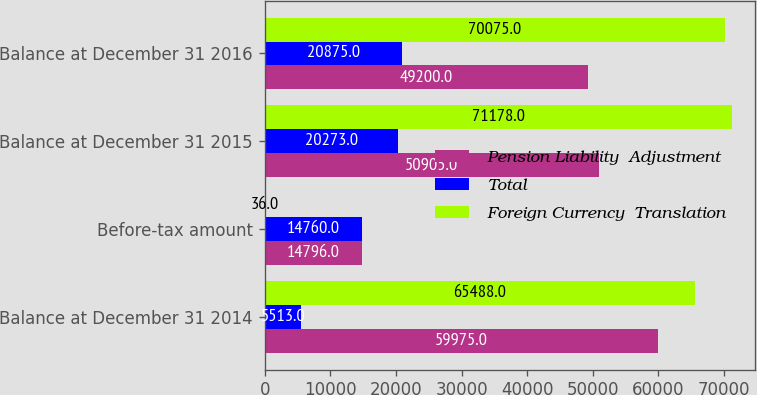Convert chart. <chart><loc_0><loc_0><loc_500><loc_500><stacked_bar_chart><ecel><fcel>Balance at December 31 2014<fcel>Before-tax amount<fcel>Balance at December 31 2015<fcel>Balance at December 31 2016<nl><fcel>Pension Liability  Adjustment<fcel>59975<fcel>14796<fcel>50905<fcel>49200<nl><fcel>Total<fcel>5513<fcel>14760<fcel>20273<fcel>20875<nl><fcel>Foreign Currency  Translation<fcel>65488<fcel>36<fcel>71178<fcel>70075<nl></chart> 